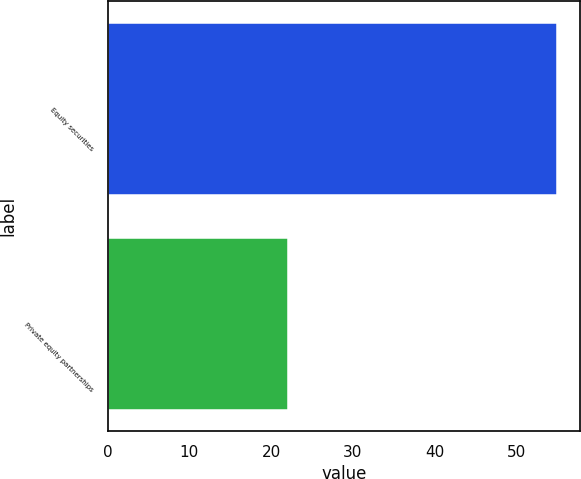<chart> <loc_0><loc_0><loc_500><loc_500><bar_chart><fcel>Equity securities<fcel>Private equity partnerships<nl><fcel>55<fcel>22<nl></chart> 